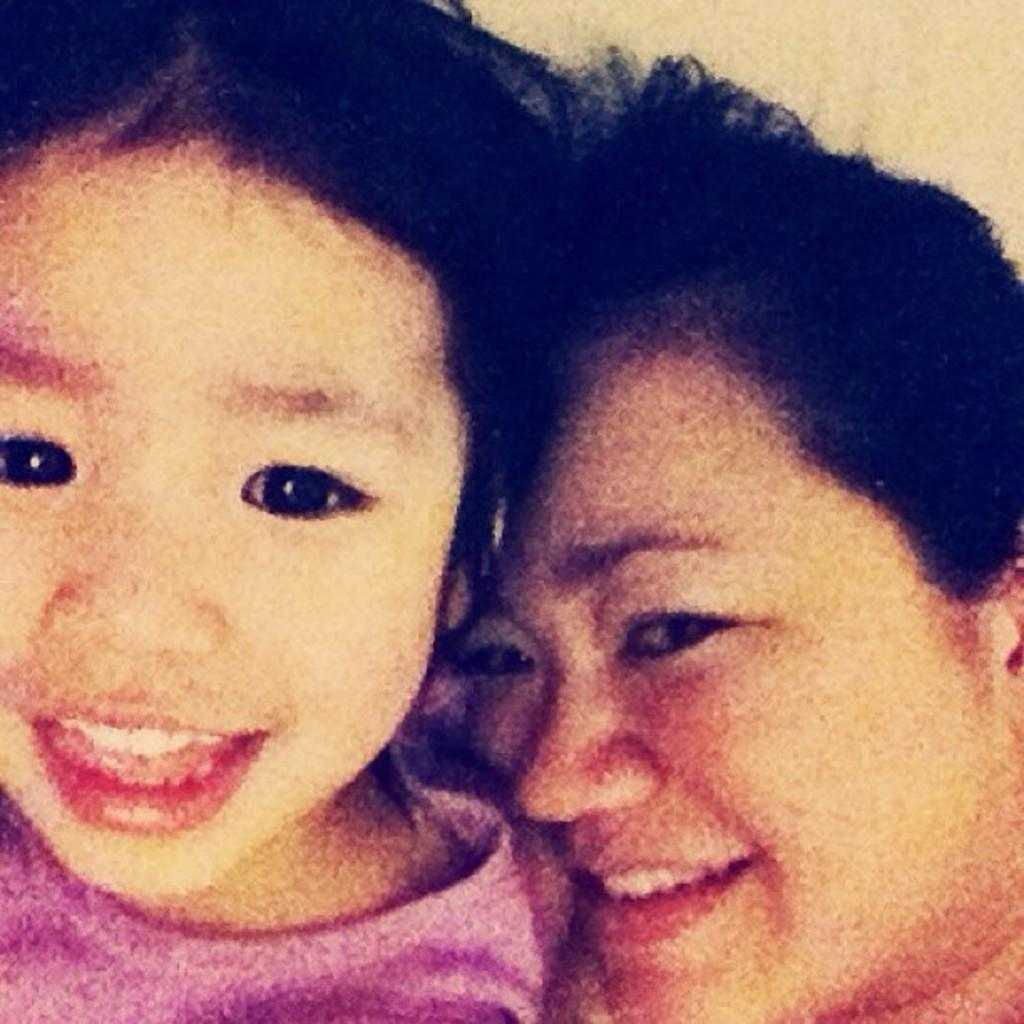Who is present in the image? There is a woman and a girl in the image. What is the facial expression of the woman in the image? The woman is smiling in the image. What is the facial expression of the girl in the image? The girl is also smiling in the image. What type of rod can be seen providing comfort to the girl in the image? There is no rod present in the image, and the girl is not shown receiving comfort from any object. 